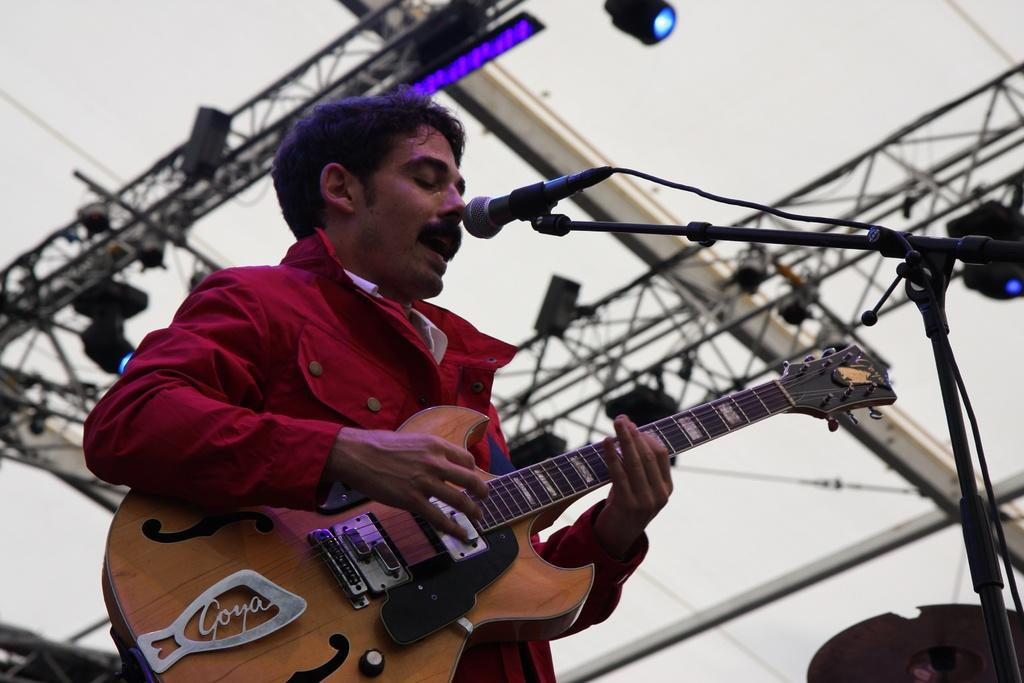What is the man in the image doing? The man is playing a guitar and singing. What instrument is the man using in the image? The man is playing a guitar. What device is present for amplifying the man's voice? There is a microphone in the image. What can be seen providing illumination in the image? There is a light in the image. How many snails can be seen crawling on the man's elbow in the image? There are no snails present in the image, and therefore none can be seen crawling on the man's elbow. 